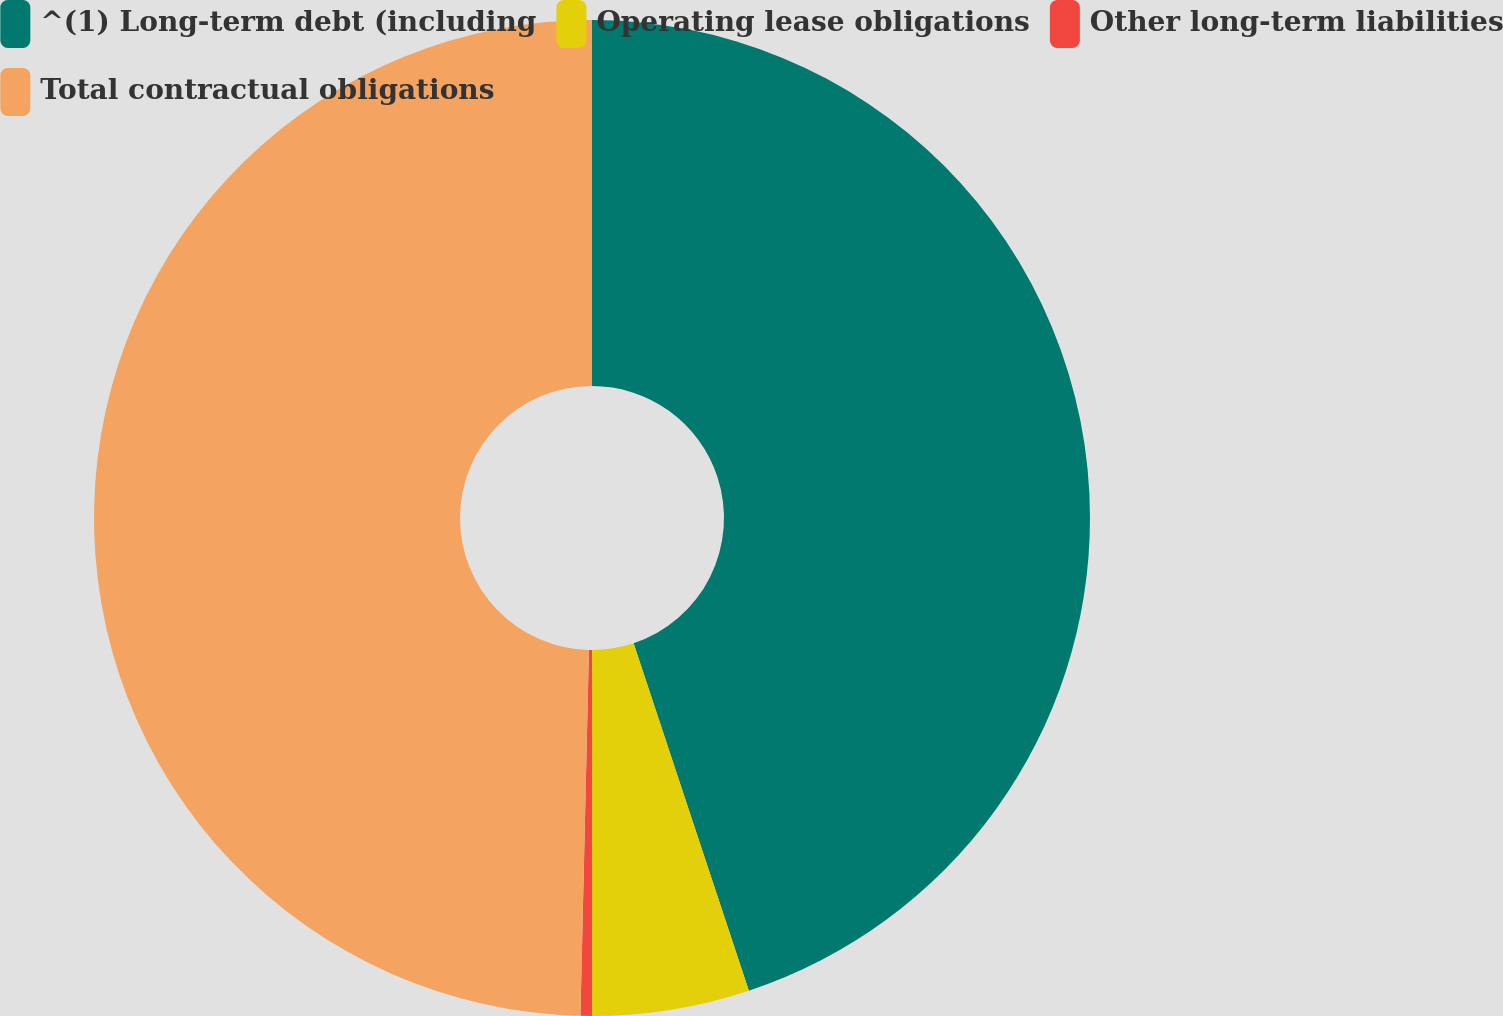<chart> <loc_0><loc_0><loc_500><loc_500><pie_chart><fcel>^(1) Long-term debt (including<fcel>Operating lease obligations<fcel>Other long-term liabilities<fcel>Total contractual obligations<nl><fcel>44.9%<fcel>5.1%<fcel>0.37%<fcel>49.63%<nl></chart> 